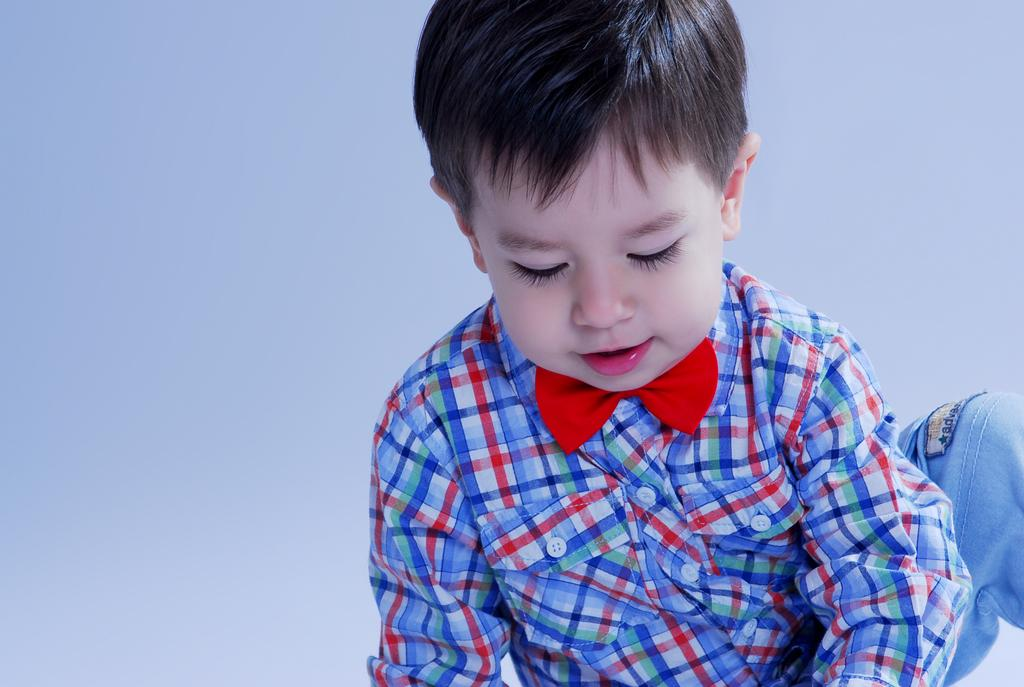What is the main subject of the image? There is a child in the image. What is the child wearing on their upper body? The child is wearing a shirt. What type of pants is the child wearing? The child is wearing blue jeans. What color is the background of the image? The background of the image is white. What type of coil is visible on the child's shirt in the image? There is no coil visible on the child's shirt in the image. What decisions is the committee making in the image? There is no committee present in the image, so no decisions are being made. 